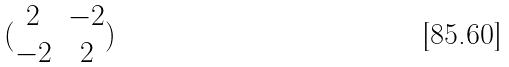Convert formula to latex. <formula><loc_0><loc_0><loc_500><loc_500>( \begin{matrix} 2 & - 2 \\ - 2 & 2 \end{matrix} )</formula> 